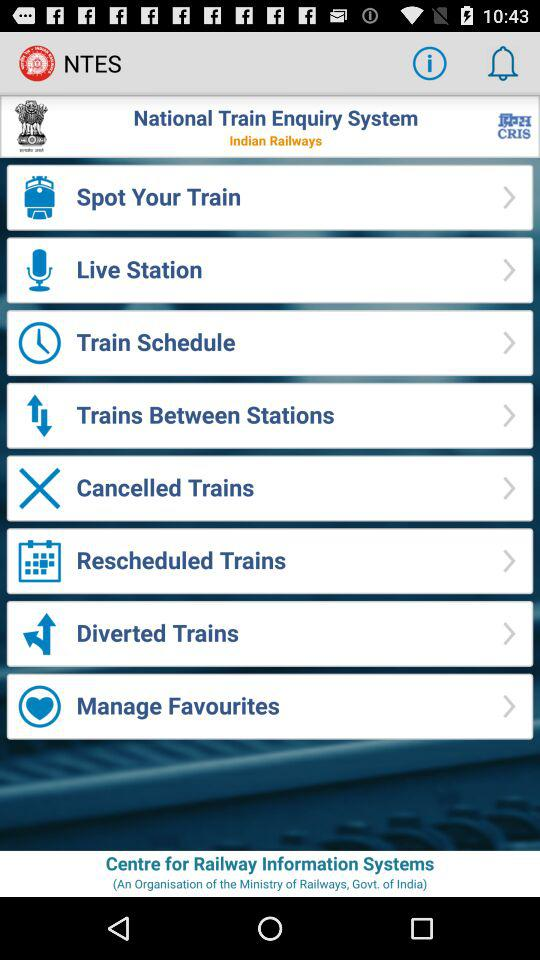How much is the train ticket?
When the provided information is insufficient, respond with <no answer>. <no answer> 